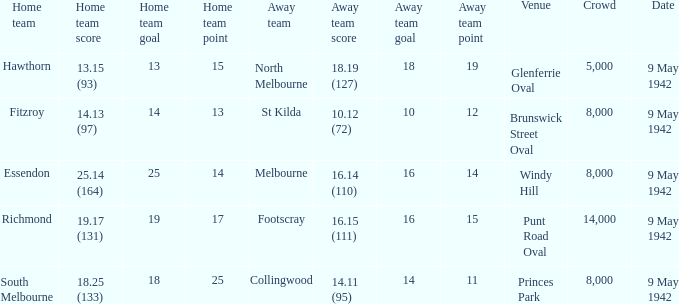How many people attended the game where Footscray was away? 14000.0. 